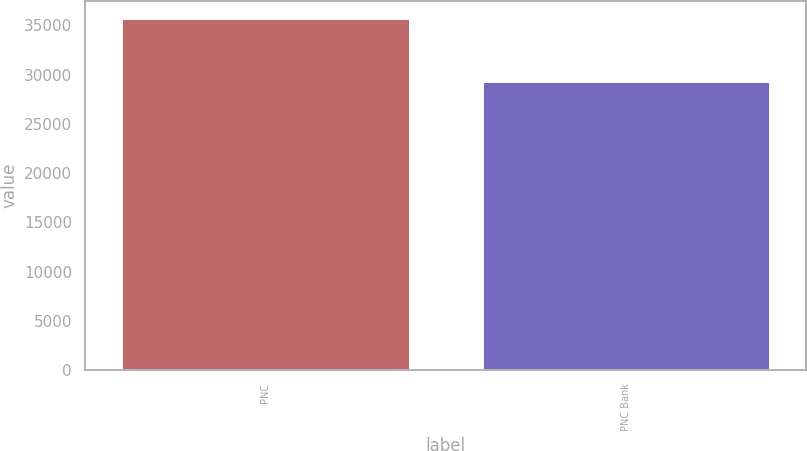Convert chart to OTSL. <chart><loc_0><loc_0><loc_500><loc_500><bar_chart><fcel>PNC<fcel>PNC Bank<nl><fcel>35687<fcel>29328<nl></chart> 